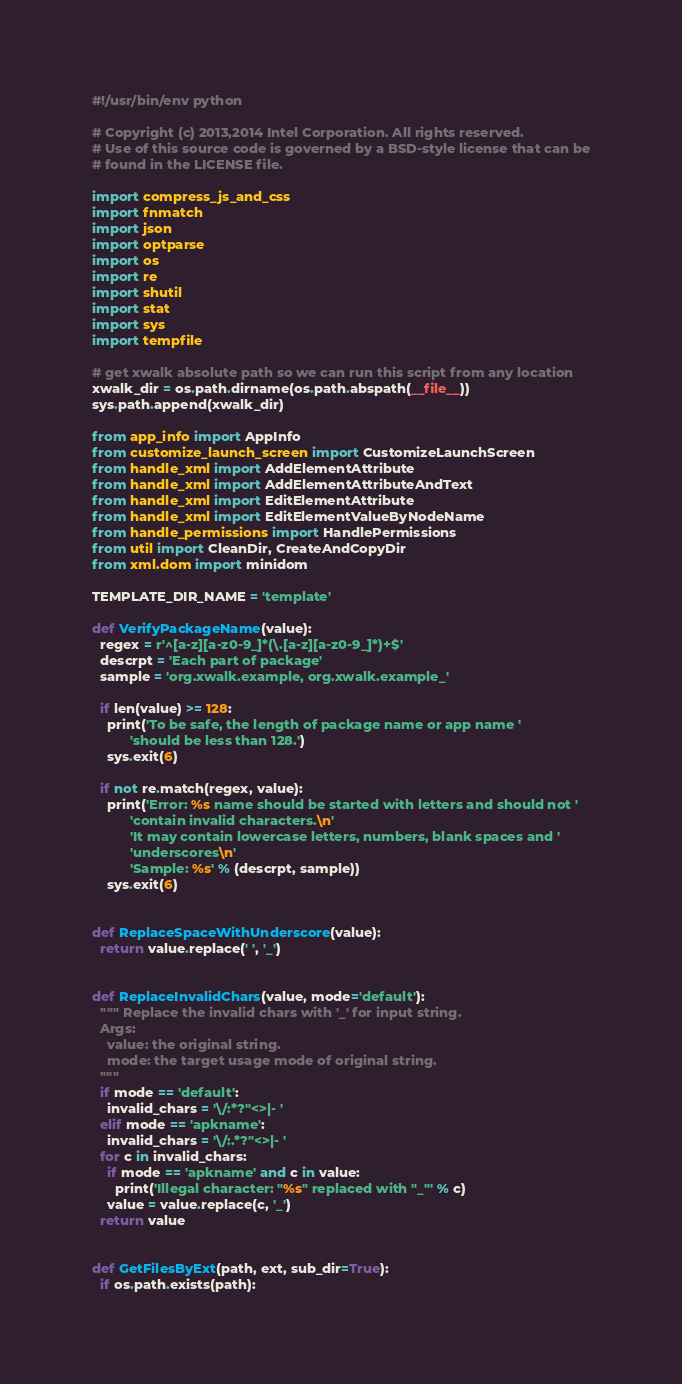<code> <loc_0><loc_0><loc_500><loc_500><_Python_>#!/usr/bin/env python

# Copyright (c) 2013,2014 Intel Corporation. All rights reserved.
# Use of this source code is governed by a BSD-style license that can be
# found in the LICENSE file.

import compress_js_and_css
import fnmatch
import json
import optparse
import os
import re
import shutil
import stat
import sys
import tempfile

# get xwalk absolute path so we can run this script from any location
xwalk_dir = os.path.dirname(os.path.abspath(__file__))
sys.path.append(xwalk_dir)

from app_info import AppInfo
from customize_launch_screen import CustomizeLaunchScreen
from handle_xml import AddElementAttribute
from handle_xml import AddElementAttributeAndText
from handle_xml import EditElementAttribute
from handle_xml import EditElementValueByNodeName
from handle_permissions import HandlePermissions
from util import CleanDir, CreateAndCopyDir
from xml.dom import minidom

TEMPLATE_DIR_NAME = 'template'

def VerifyPackageName(value):
  regex = r'^[a-z][a-z0-9_]*(\.[a-z][a-z0-9_]*)+$'
  descrpt = 'Each part of package'
  sample = 'org.xwalk.example, org.xwalk.example_'

  if len(value) >= 128:
    print('To be safe, the length of package name or app name '
          'should be less than 128.')
    sys.exit(6)

  if not re.match(regex, value):
    print('Error: %s name should be started with letters and should not '
          'contain invalid characters.\n'
          'It may contain lowercase letters, numbers, blank spaces and '
          'underscores\n'
          'Sample: %s' % (descrpt, sample))
    sys.exit(6)


def ReplaceSpaceWithUnderscore(value):
  return value.replace(' ', '_')


def ReplaceInvalidChars(value, mode='default'):
  """ Replace the invalid chars with '_' for input string.
  Args:
    value: the original string.
    mode: the target usage mode of original string.
  """
  if mode == 'default':
    invalid_chars = '\/:*?"<>|- '
  elif mode == 'apkname':
    invalid_chars = '\/:.*?"<>|- '
  for c in invalid_chars:
    if mode == 'apkname' and c in value:
      print('Illegal character: "%s" replaced with "_"' % c)
    value = value.replace(c, '_')
  return value


def GetFilesByExt(path, ext, sub_dir=True):
  if os.path.exists(path):</code> 